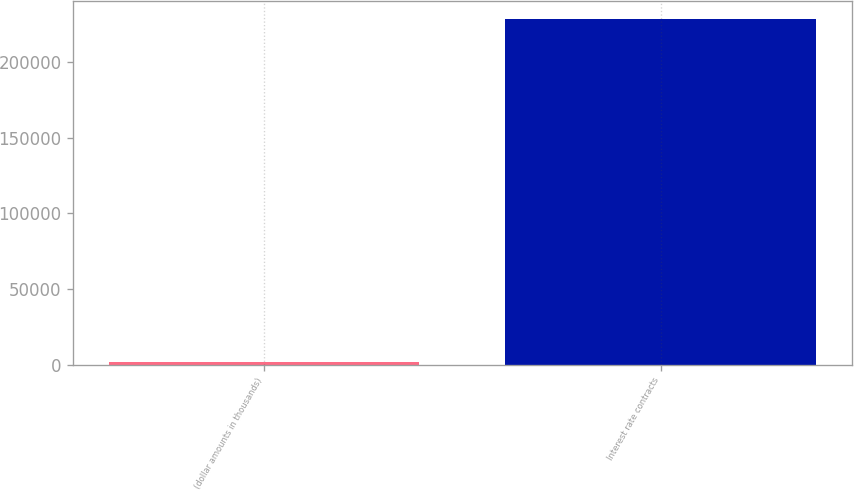Convert chart to OTSL. <chart><loc_0><loc_0><loc_500><loc_500><bar_chart><fcel>(dollar amounts in thousands)<fcel>Interest rate contracts<nl><fcel>2012<fcel>228757<nl></chart> 